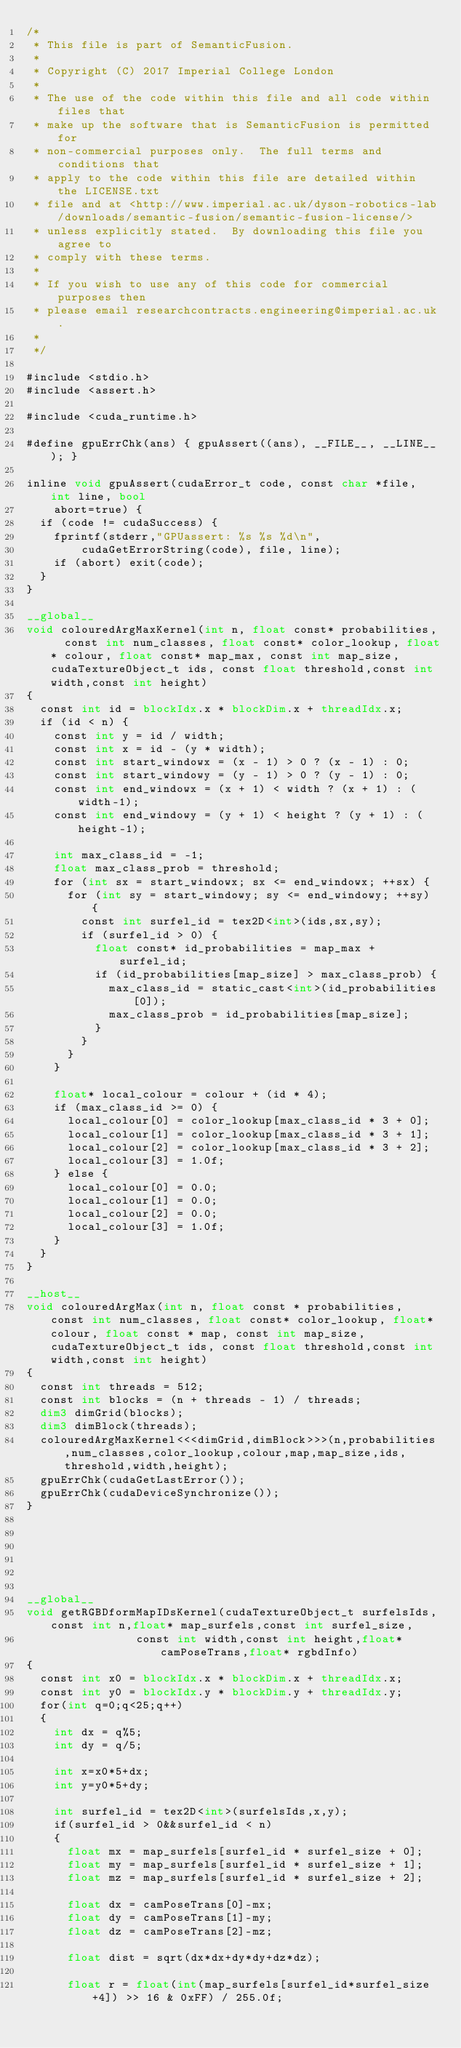Convert code to text. <code><loc_0><loc_0><loc_500><loc_500><_Cuda_>/*
 * This file is part of SemanticFusion.
 *
 * Copyright (C) 2017 Imperial College London
 * 
 * The use of the code within this file and all code within files that 
 * make up the software that is SemanticFusion is permitted for 
 * non-commercial purposes only.  The full terms and conditions that 
 * apply to the code within this file are detailed within the LICENSE.txt 
 * file and at <http://www.imperial.ac.uk/dyson-robotics-lab/downloads/semantic-fusion/semantic-fusion-license/> 
 * unless explicitly stated.  By downloading this file you agree to 
 * comply with these terms.
 *
 * If you wish to use any of this code for commercial purposes then 
 * please email researchcontracts.engineering@imperial.ac.uk.
 *
 */

#include <stdio.h>
#include <assert.h> 

#include <cuda_runtime.h>

#define gpuErrChk(ans) { gpuAssert((ans), __FILE__, __LINE__); }

inline void gpuAssert(cudaError_t code, const char *file, int line, bool
		abort=true) {
	if (code != cudaSuccess) {
		fprintf(stderr,"GPUassert: %s %s %d\n",
				cudaGetErrorString(code), file, line);
		if (abort) exit(code);
	} 
}

__global__ 
void colouredArgMaxKernel(int n, float const* probabilities,  const int num_classes, float const* color_lookup, float* colour, float const* map_max, const int map_size,cudaTextureObject_t ids, const float threshold,const int width,const int height)
{
	const int id = blockIdx.x * blockDim.x + threadIdx.x;
	if (id < n) {
		const int y = id / width;
		const int x = id - (y * width);
		const int start_windowx = (x - 1) > 0 ? (x - 1) : 0;
		const int start_windowy = (y - 1) > 0 ? (y - 1) : 0;
		const int end_windowx = (x + 1) < width ? (x + 1) : (width-1);
		const int end_windowy = (y + 1) < height ? (y + 1) : (height-1);

		int max_class_id = -1;
		float max_class_prob = threshold;
		for (int sx = start_windowx; sx <= end_windowx; ++sx) {
			for (int sy = start_windowy; sy <= end_windowy; ++sy) {
				const int surfel_id = tex2D<int>(ids,sx,sy);
				if (surfel_id > 0) {
					float const* id_probabilities = map_max + surfel_id;
					if (id_probabilities[map_size] > max_class_prob) {
						max_class_id = static_cast<int>(id_probabilities[0]);
						max_class_prob = id_probabilities[map_size];
					}
				}
			}
		}

		float* local_colour = colour + (id * 4);
		if (max_class_id >= 0) {
			local_colour[0] = color_lookup[max_class_id * 3 + 0];
			local_colour[1] = color_lookup[max_class_id * 3 + 1];
			local_colour[2] = color_lookup[max_class_id * 3 + 2];
			local_colour[3] = 1.0f;
		} else {
			local_colour[0] = 0.0;
			local_colour[1] = 0.0;
			local_colour[2] = 0.0;
			local_colour[3] = 1.0f;
		}
	}
}

__host__
void colouredArgMax(int n, float const * probabilities,  const int num_classes, float const* color_lookup, float* colour, float const * map, const int map_size,cudaTextureObject_t ids, const float threshold,const int width,const int height)
{
	const int threads = 512;
	const int blocks = (n + threads - 1) / threads;
	dim3 dimGrid(blocks);
	dim3 dimBlock(threads);
	colouredArgMaxKernel<<<dimGrid,dimBlock>>>(n,probabilities,num_classes,color_lookup,colour,map,map_size,ids,threshold,width,height);
	gpuErrChk(cudaGetLastError());
	gpuErrChk(cudaDeviceSynchronize());
}






__global__
void getRGBDformMapIDsKernel(cudaTextureObject_t surfelsIds,const int n,float* map_surfels,const int surfel_size,
								const int width,const int height,float* camPoseTrans,float* rgbdInfo)
{
	const int x0 = blockIdx.x * blockDim.x + threadIdx.x;
	const int y0 = blockIdx.y * blockDim.y + threadIdx.y;
	for(int q=0;q<25;q++)
	{
		int dx = q%5;
		int dy = q/5;

		int x=x0*5+dx;
		int y=y0*5+dy;

		int surfel_id = tex2D<int>(surfelsIds,x,y);
		if(surfel_id > 0&&surfel_id < n)
		{
			float mx = map_surfels[surfel_id * surfel_size + 0];
			float my = map_surfels[surfel_id * surfel_size + 1];
			float mz = map_surfels[surfel_id * surfel_size + 2];

			float dx = camPoseTrans[0]-mx;
			float dy = camPoseTrans[1]-my;
			float dz = camPoseTrans[2]-mz;
		
			float dist = sqrt(dx*dx+dy*dy+dz*dz);
		
			float r = float(int(map_surfels[surfel_id*surfel_size+4]) >> 16 & 0xFF) / 255.0f;</code> 